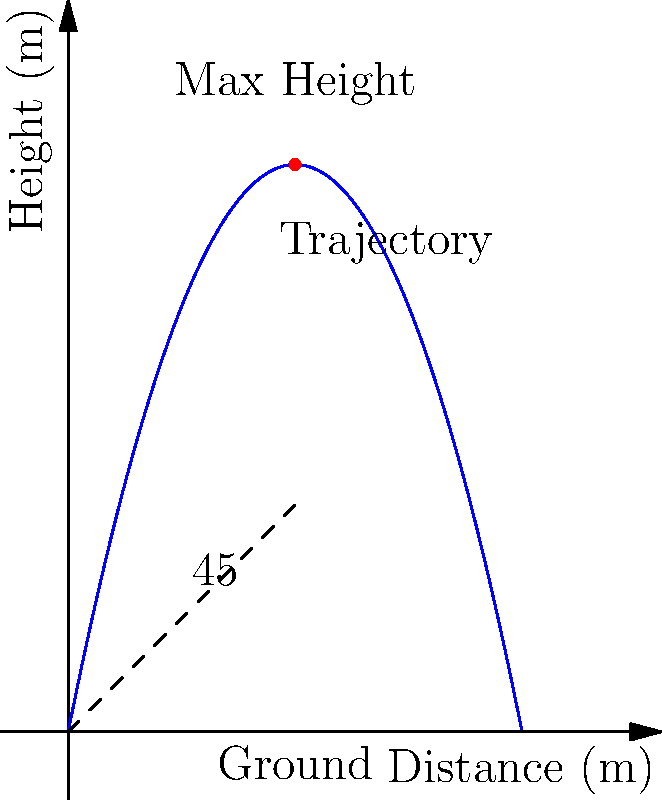As a sports psychologist working with a long jumper, you want to demonstrate the importance of the optimal takeoff angle. A jumper's trajectory can be modeled by the function $h(x) = 5x - 0.5x^2$, where $h$ is the height in meters and $x$ is the horizontal distance in meters. If the optimal takeoff angle for maximum distance is 45°, what is the cosine of this angle, and how does it relate to the jumper's initial velocity components? To solve this problem, let's break it down into steps:

1) First, recall that for a 45° angle, the cosine is equal to $\frac{1}{\sqrt{2}}$ or approximately 0.7071.

2) In projectile motion, the optimal angle for maximum distance (assuming no air resistance and level ground) is indeed 45°. This is because at this angle, the horizontal and vertical components of the initial velocity are equal.

3) The cosine of the takeoff angle represents the ratio of the horizontal component of the initial velocity to the total initial velocity:

   $\cos \theta = \frac{v_x}{v}$

   Where $v_x$ is the horizontal component of velocity and $v$ is the total initial velocity.

4) At 45°, $\cos 45° = \frac{1}{\sqrt{2}} \approx 0.7071$

5) This means that at the optimal angle, about 70.71% of the jumper's initial velocity is in the horizontal direction, and the same percentage is in the vertical direction (since $\sin 45° = \cos 45°$).

6) The equality of horizontal and vertical components at 45° maximizes the product of:
   a) Time in the air (determined by the vertical component)
   b) Horizontal velocity (determined by the horizontal component)

   This product determines the distance traveled.

7) Understanding this can help the athlete visualize and internalize the importance of the takeoff angle in utilizing their power effectively for maximum distance.
Answer: $\cos 45° = \frac{1}{\sqrt{2}} \approx 0.7071$, representing equal horizontal and vertical velocity components. 